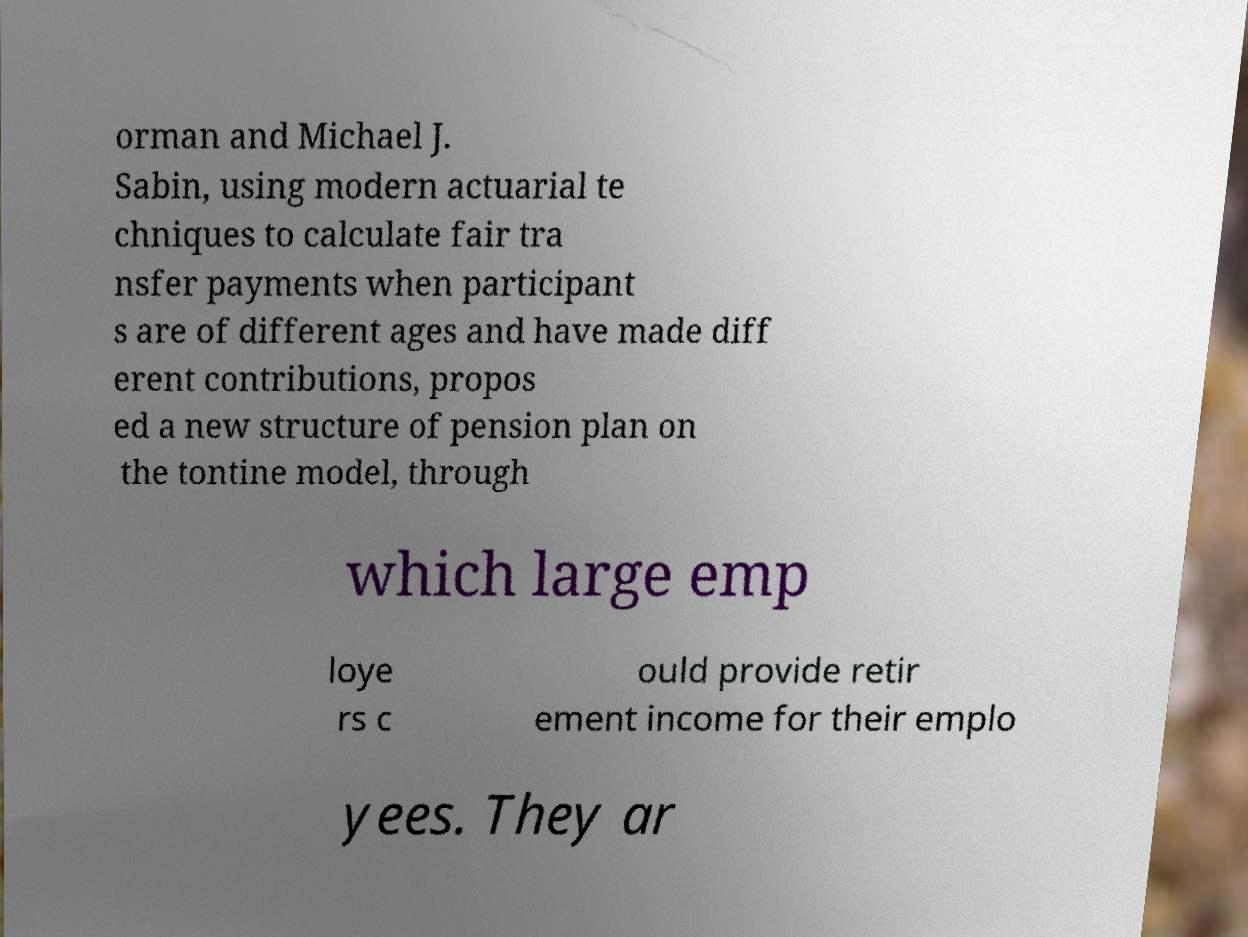I need the written content from this picture converted into text. Can you do that? orman and Michael J. Sabin, using modern actuarial te chniques to calculate fair tra nsfer payments when participant s are of different ages and have made diff erent contributions, propos ed a new structure of pension plan on the tontine model, through which large emp loye rs c ould provide retir ement income for their emplo yees. They ar 